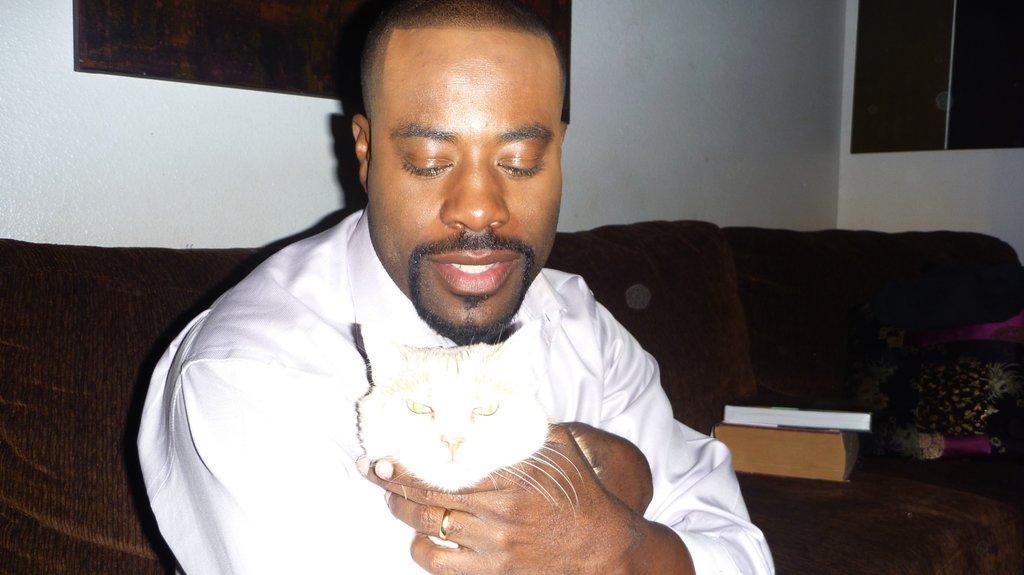Describe this image in one or two sentences. A person is holding a cat and sitting on a sofa. On the handle there are books. In the background there is a wall. 